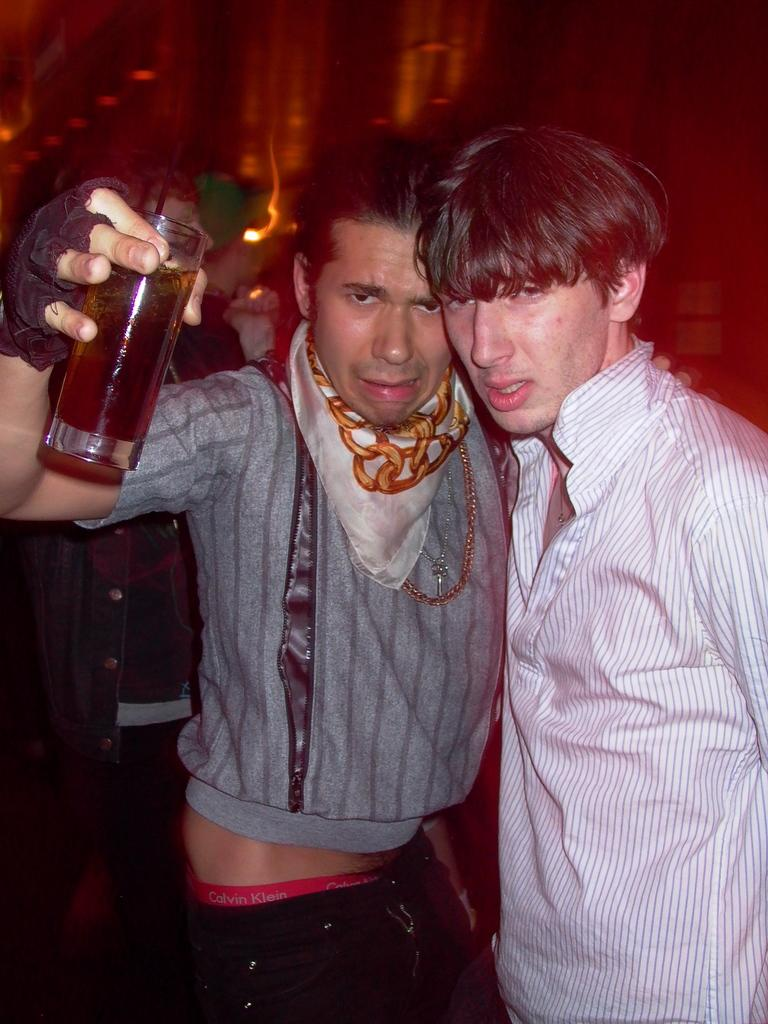How many people are in the foreground of the image? There are two persons standing in the foreground of the image. What is one of the persons in the foreground holding? One person in the foreground is holding a glass. Can you describe the background of the image? There is another person in the background of the image, and there are lights visible in the background. How many toes does the person in the background have in the image? There is no information about the number of toes of the person in the background, as the image does not show their feet. 